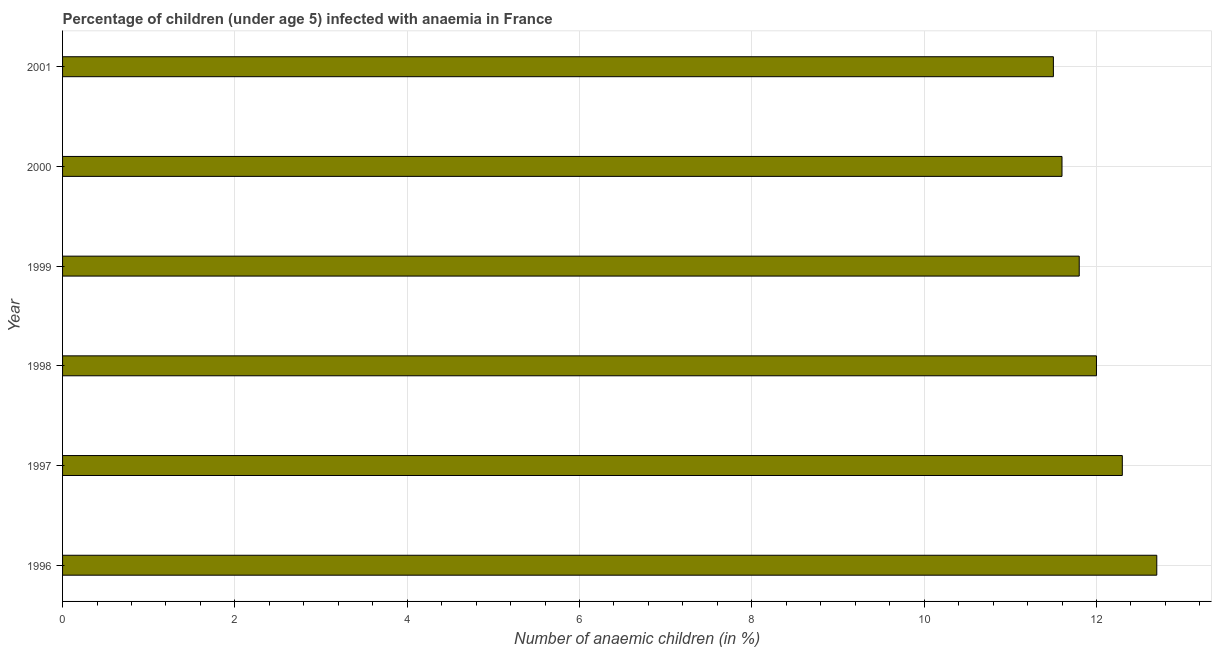Does the graph contain any zero values?
Provide a succinct answer. No. Does the graph contain grids?
Offer a terse response. Yes. What is the title of the graph?
Provide a succinct answer. Percentage of children (under age 5) infected with anaemia in France. What is the label or title of the X-axis?
Make the answer very short. Number of anaemic children (in %). What is the number of anaemic children in 1996?
Provide a short and direct response. 12.7. Across all years, what is the maximum number of anaemic children?
Your answer should be very brief. 12.7. Across all years, what is the minimum number of anaemic children?
Offer a very short reply. 11.5. In which year was the number of anaemic children minimum?
Give a very brief answer. 2001. What is the sum of the number of anaemic children?
Provide a short and direct response. 71.9. What is the difference between the number of anaemic children in 1998 and 1999?
Provide a succinct answer. 0.2. What is the average number of anaemic children per year?
Keep it short and to the point. 11.98. Do a majority of the years between 2000 and 1996 (inclusive) have number of anaemic children greater than 7.6 %?
Offer a very short reply. Yes. What is the ratio of the number of anaemic children in 1998 to that in 2001?
Make the answer very short. 1.04. Is the number of anaemic children in 1998 less than that in 1999?
Offer a very short reply. No. What is the difference between the highest and the second highest number of anaemic children?
Offer a terse response. 0.4. What is the difference between the highest and the lowest number of anaemic children?
Offer a terse response. 1.2. In how many years, is the number of anaemic children greater than the average number of anaemic children taken over all years?
Offer a terse response. 3. How many bars are there?
Your answer should be very brief. 6. Are all the bars in the graph horizontal?
Your answer should be compact. Yes. What is the difference between two consecutive major ticks on the X-axis?
Your answer should be compact. 2. Are the values on the major ticks of X-axis written in scientific E-notation?
Provide a succinct answer. No. What is the Number of anaemic children (in %) of 1997?
Ensure brevity in your answer.  12.3. What is the Number of anaemic children (in %) in 1998?
Provide a short and direct response. 12. What is the Number of anaemic children (in %) of 2001?
Ensure brevity in your answer.  11.5. What is the difference between the Number of anaemic children (in %) in 1996 and 1997?
Offer a very short reply. 0.4. What is the difference between the Number of anaemic children (in %) in 1997 and 1998?
Your answer should be very brief. 0.3. What is the difference between the Number of anaemic children (in %) in 1997 and 2001?
Your answer should be very brief. 0.8. What is the difference between the Number of anaemic children (in %) in 1998 and 1999?
Give a very brief answer. 0.2. What is the difference between the Number of anaemic children (in %) in 1998 and 2000?
Your answer should be very brief. 0.4. What is the difference between the Number of anaemic children (in %) in 2000 and 2001?
Offer a terse response. 0.1. What is the ratio of the Number of anaemic children (in %) in 1996 to that in 1997?
Provide a short and direct response. 1.03. What is the ratio of the Number of anaemic children (in %) in 1996 to that in 1998?
Give a very brief answer. 1.06. What is the ratio of the Number of anaemic children (in %) in 1996 to that in 1999?
Your answer should be compact. 1.08. What is the ratio of the Number of anaemic children (in %) in 1996 to that in 2000?
Give a very brief answer. 1.09. What is the ratio of the Number of anaemic children (in %) in 1996 to that in 2001?
Give a very brief answer. 1.1. What is the ratio of the Number of anaemic children (in %) in 1997 to that in 1999?
Your answer should be compact. 1.04. What is the ratio of the Number of anaemic children (in %) in 1997 to that in 2000?
Make the answer very short. 1.06. What is the ratio of the Number of anaemic children (in %) in 1997 to that in 2001?
Ensure brevity in your answer.  1.07. What is the ratio of the Number of anaemic children (in %) in 1998 to that in 1999?
Keep it short and to the point. 1.02. What is the ratio of the Number of anaemic children (in %) in 1998 to that in 2000?
Your answer should be compact. 1.03. What is the ratio of the Number of anaemic children (in %) in 1998 to that in 2001?
Your response must be concise. 1.04. What is the ratio of the Number of anaemic children (in %) in 1999 to that in 2000?
Your response must be concise. 1.02. What is the ratio of the Number of anaemic children (in %) in 1999 to that in 2001?
Provide a short and direct response. 1.03. What is the ratio of the Number of anaemic children (in %) in 2000 to that in 2001?
Give a very brief answer. 1.01. 